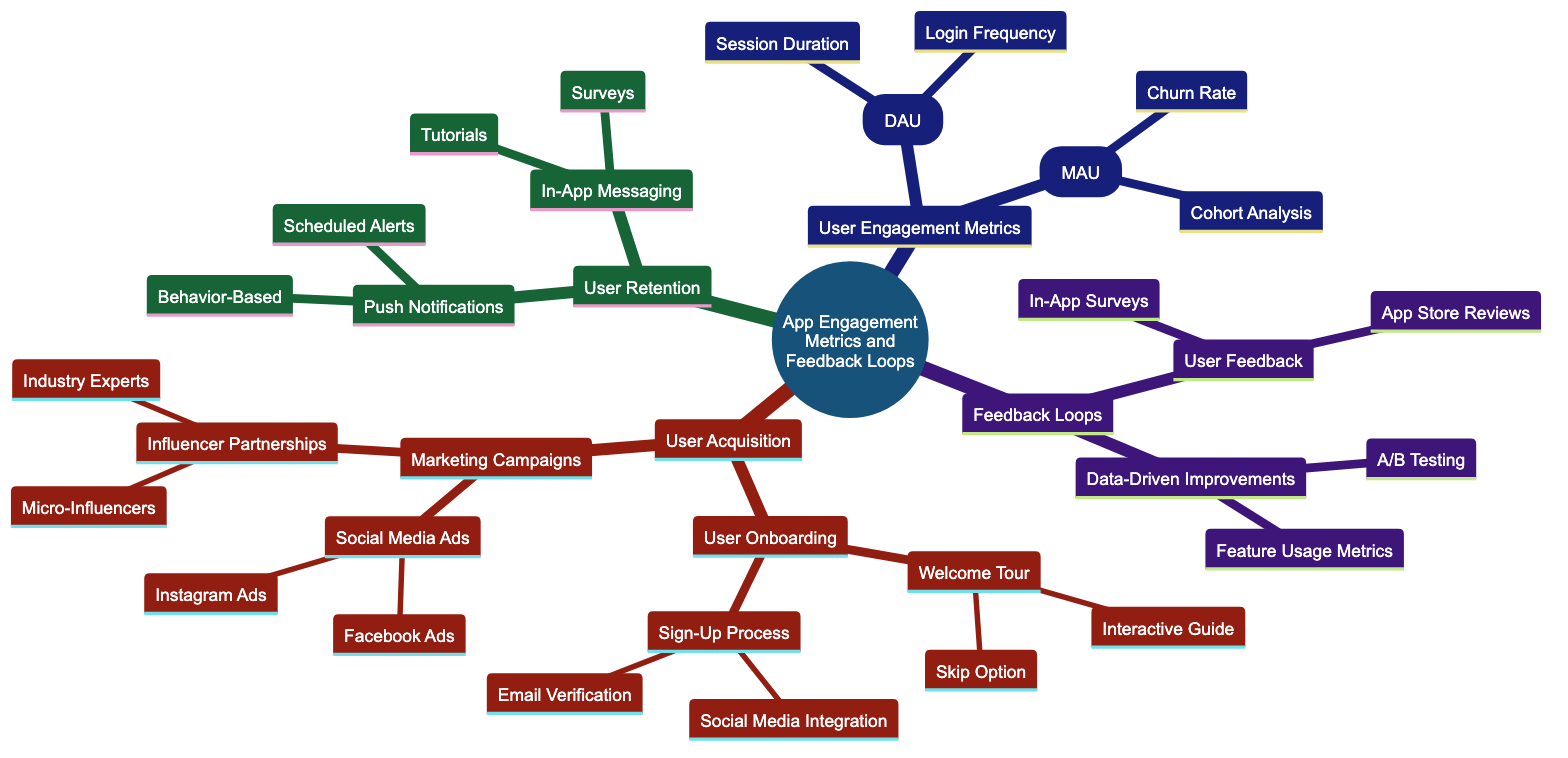What is the root node of the diagram? The root node is the topmost element of the diagram, and in this case, it is "App Engagement Metrics and Feedback Loops."
Answer: App Engagement Metrics and Feedback Loops How many categories are under User Engagement Metrics? There are two children nodes under User Engagement Metrics: Daily Active Users (DAU) and Monthly Active Users (MAU).
Answer: 2 What child node comes after Marketing Campaigns? In the hierarchy under User Acquisition, the child node following Marketing Campaigns is User Retention.
Answer: User Retention What are the two types of User Onboarding strategies mentioned? The two types of User Onboarding strategies listed are Welcome Tour and Sign-Up Process.
Answer: Welcome Tour and Sign-Up Process Which marketing strategy involves influencers? Influencer Partnerships is the marketing strategy that directly involves influencers.
Answer: Influencer Partnerships What is a way to measure Monthly Active Users? Churn Rate is one of the metrics used to measure Monthly Active Users.
Answer: Churn Rate How are Push Notifications categorized? Push Notifications are categorized into Behavior-Based and Scheduled Alerts.
Answer: Behavior-Based and Scheduled Alerts What type of feedback is associated with User Feedback loops? App Store Reviews are a type of feedback associated with the User Feedback loop.
Answer: App Store Reviews Which metrics can help improve app features? A/B Testing is one of the metrics that can help improve app features based on collected data.
Answer: A/B Testing 